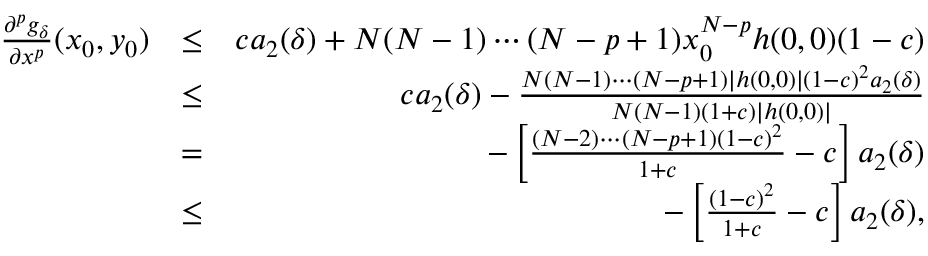Convert formula to latex. <formula><loc_0><loc_0><loc_500><loc_500>\begin{array} { r l r } { \frac { \partial ^ { p } g _ { \delta } } { \partial x ^ { p } } ( x _ { 0 } , y _ { 0 } ) } & { \leq } & { c a _ { 2 } ( \delta ) + N ( N - 1 ) \cdots ( N - p + 1 ) x _ { 0 } ^ { N - p } h ( 0 , 0 ) ( 1 - c ) } \\ & { \leq } & { c a _ { 2 } ( \delta ) - \frac { N ( N - 1 ) \cdots ( N - p + 1 ) | h ( 0 , 0 ) | ( 1 - c ) ^ { 2 } a _ { 2 } ( \delta ) } { N ( N - 1 ) ( 1 + c ) | h ( 0 , 0 ) | } } \\ & { = } & { - \left [ \frac { ( N - 2 ) \cdots ( N - p + 1 ) ( 1 - c ) ^ { 2 } } { 1 + c } - c \right ] a _ { 2 } ( \delta ) } \\ & { \leq } & { - \left [ \frac { ( 1 - c ) ^ { 2 } } { 1 + c } - c \right ] a _ { 2 } ( \delta ) , } \end{array}</formula> 